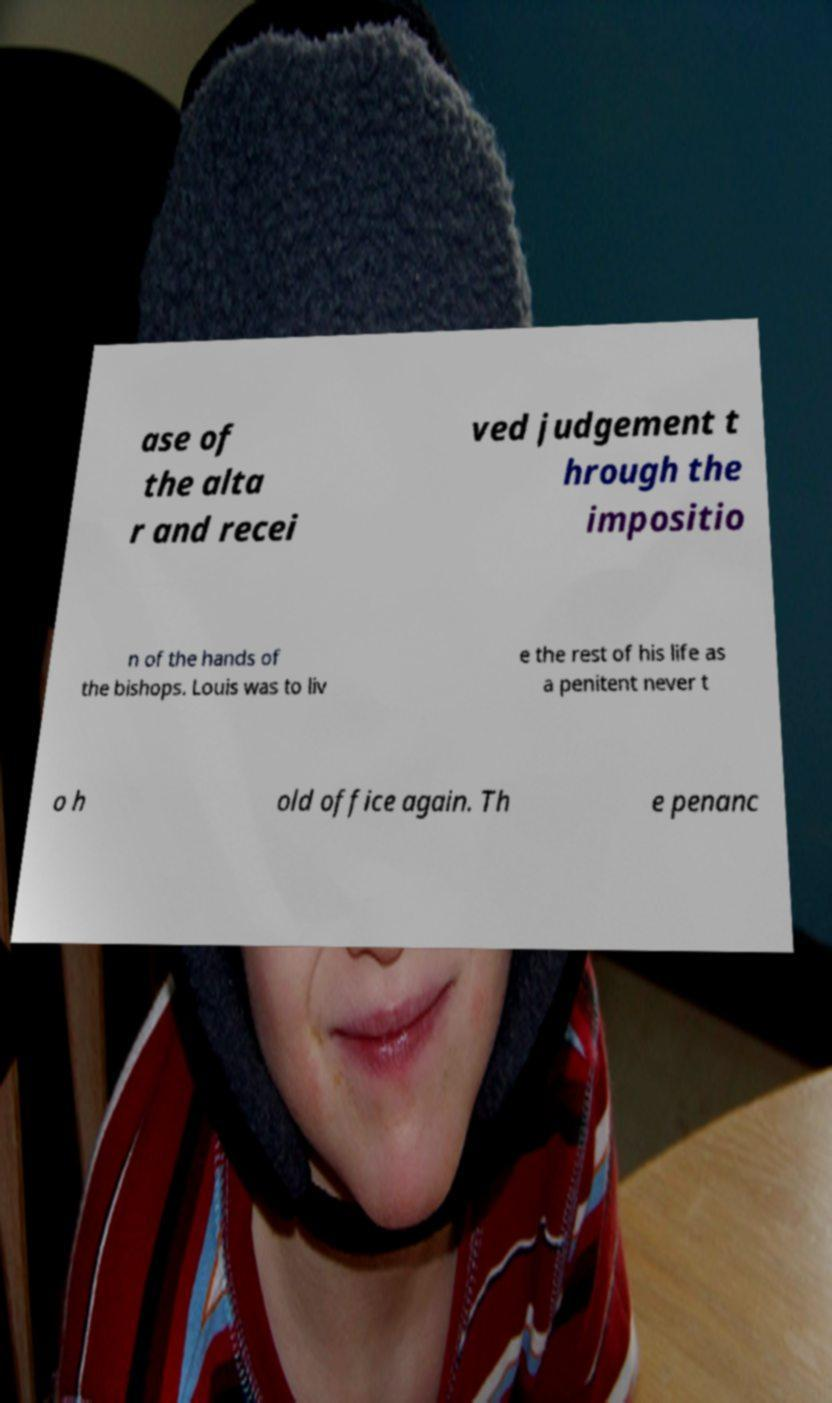Could you extract and type out the text from this image? ase of the alta r and recei ved judgement t hrough the impositio n of the hands of the bishops. Louis was to liv e the rest of his life as a penitent never t o h old office again. Th e penanc 